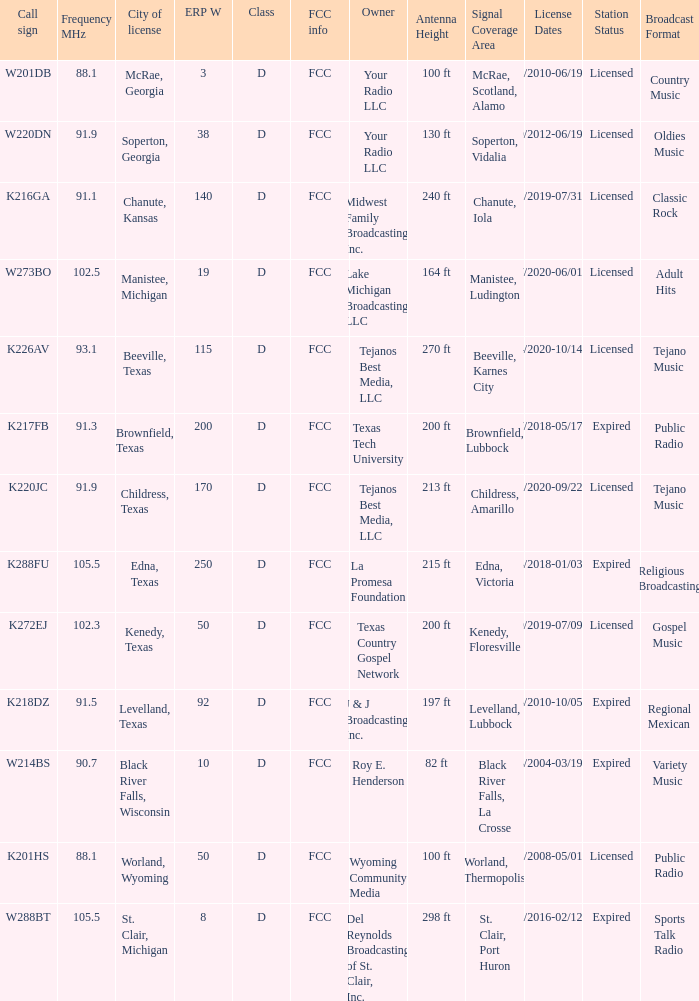What is the Sum of ERP W, when Call Sign is K216GA? 140.0. Could you parse the entire table as a dict? {'header': ['Call sign', 'Frequency MHz', 'City of license', 'ERP W', 'Class', 'FCC info', 'Owner', 'Antenna Height', 'Signal Coverage Area', 'License Dates', 'Station Status', 'Broadcast Format'], 'rows': [['W201DB', '88.1', 'McRae, Georgia', '3', 'D', 'FCC', 'Your Radio LLC', '100 ft', 'McRae, Scotland, Alamo', '07/01/2010-06/19/2021', 'Licensed', 'Country Music'], ['W220DN', '91.9', 'Soperton, Georgia', '38', 'D', 'FCC', 'Your Radio LLC', '130 ft', 'Soperton, Vidalia', '10/09/2012-06/19/2021', 'Licensed', 'Oldies Music'], ['K216GA', '91.1', 'Chanute, Kansas', '140', 'D', 'FCC', 'Midwest Family Broadcasting, Inc.', '240 ft', 'Chanute, Iola', '07/31/2019-07/31/2022', 'Licensed', 'Classic Rock'], ['W273BO', '102.5', 'Manistee, Michigan', '19', 'D', 'FCC', 'Lake Michigan Broadcasting, LLC', '164 ft', 'Manistee, Ludington', '10/27/2020-06/01/2022', 'Licensed', 'Adult Hits'], ['K226AV', '93.1', 'Beeville, Texas', '115', 'D', 'FCC', 'Tejanos Best Media, LLC', '270 ft', 'Beeville, Karnes City', '10/14/2020-10/14/2023', 'Licensed', 'Tejano Music'], ['K217FB', '91.3', 'Brownfield, Texas', '200', 'D', 'FCC', 'Texas Tech University', '200 ft', 'Brownfield, Lubbock', '05/17/2018-05/17/2021', 'Expired', 'Public Radio'], ['K220JC', '91.9', 'Childress, Texas', '170', 'D', 'FCC', 'Tejanos Best Media, LLC', '213 ft', 'Childress, Amarillo', '09/22/2020-09/22/2023', 'Licensed', 'Tejano Music'], ['K288FU', '105.5', 'Edna, Texas', '250', 'D', 'FCC', 'La Promesa Foundation', '215 ft', 'Edna, Victoria', '01/03/2018-01/03/2021', 'Expired', 'Religious Broadcasting'], ['K272EJ', '102.3', 'Kenedy, Texas', '50', 'D', 'FCC', 'Texas Country Gospel Network', '200 ft', 'Kenedy, Floresville', '07/09/2019-07/09/2022', 'Licensed', 'Gospel Music'], ['K218DZ', '91.5', 'Levelland, Texas', '92', 'D', 'FCC', 'J & J Broadcasting, Inc.', '197 ft', 'Levelland, Lubbock', '10/05/2010-10/05/2020', 'Expired', 'Regional Mexican'], ['W214BS', '90.7', 'Black River Falls, Wisconsin', '10', 'D', 'FCC', 'Roy E. Henderson', '82 ft', 'Black River Falls, La Crosse', '10/18/2004-03/19/2017', 'Expired', 'Variety Music'], ['K201HS', '88.1', 'Worland, Wyoming', '50', 'D', 'FCC', 'Wyoming Community Media', '100 ft', 'Worland, Thermopolis', '05/01/2008-05/01/2021', 'Licensed', 'Public Radio'], ['W288BT', '105.5', 'St. Clair, Michigan', '8', 'D', 'FCC', 'Del Reynolds Broadcasting of St. Clair, Inc.', '298 ft', 'St. Clair, Port Huron', '02/12/2016-02/12/2019', 'Expired', 'Sports Talk Radio']]} 